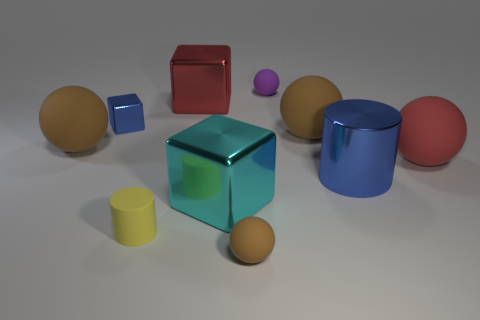What size is the object that is the same color as the small cube?
Your answer should be very brief. Large. What is the material of the large red object that is to the left of the brown object that is in front of the shiny cylinder?
Your answer should be very brief. Metal. How many large cubes are in front of the large matte thing to the left of the cylinder that is in front of the big cyan metal block?
Your answer should be compact. 1. Is the material of the tiny object in front of the tiny cylinder the same as the tiny purple object to the right of the cyan object?
Give a very brief answer. Yes. What is the material of the large thing that is the same color as the small block?
Give a very brief answer. Metal. How many big brown rubber objects are the same shape as the tiny brown object?
Keep it short and to the point. 2. Is the number of metallic things that are right of the cyan metal cube greater than the number of blue shiny cubes?
Provide a short and direct response. No. What is the shape of the large metal thing that is behind the blue thing on the left side of the tiny matte sphere that is behind the red matte ball?
Ensure brevity in your answer.  Cube. Is the shape of the brown thing that is left of the small blue metallic block the same as the large brown thing that is right of the small cylinder?
Your answer should be very brief. Yes. Is there anything else that has the same size as the blue cylinder?
Give a very brief answer. Yes. 